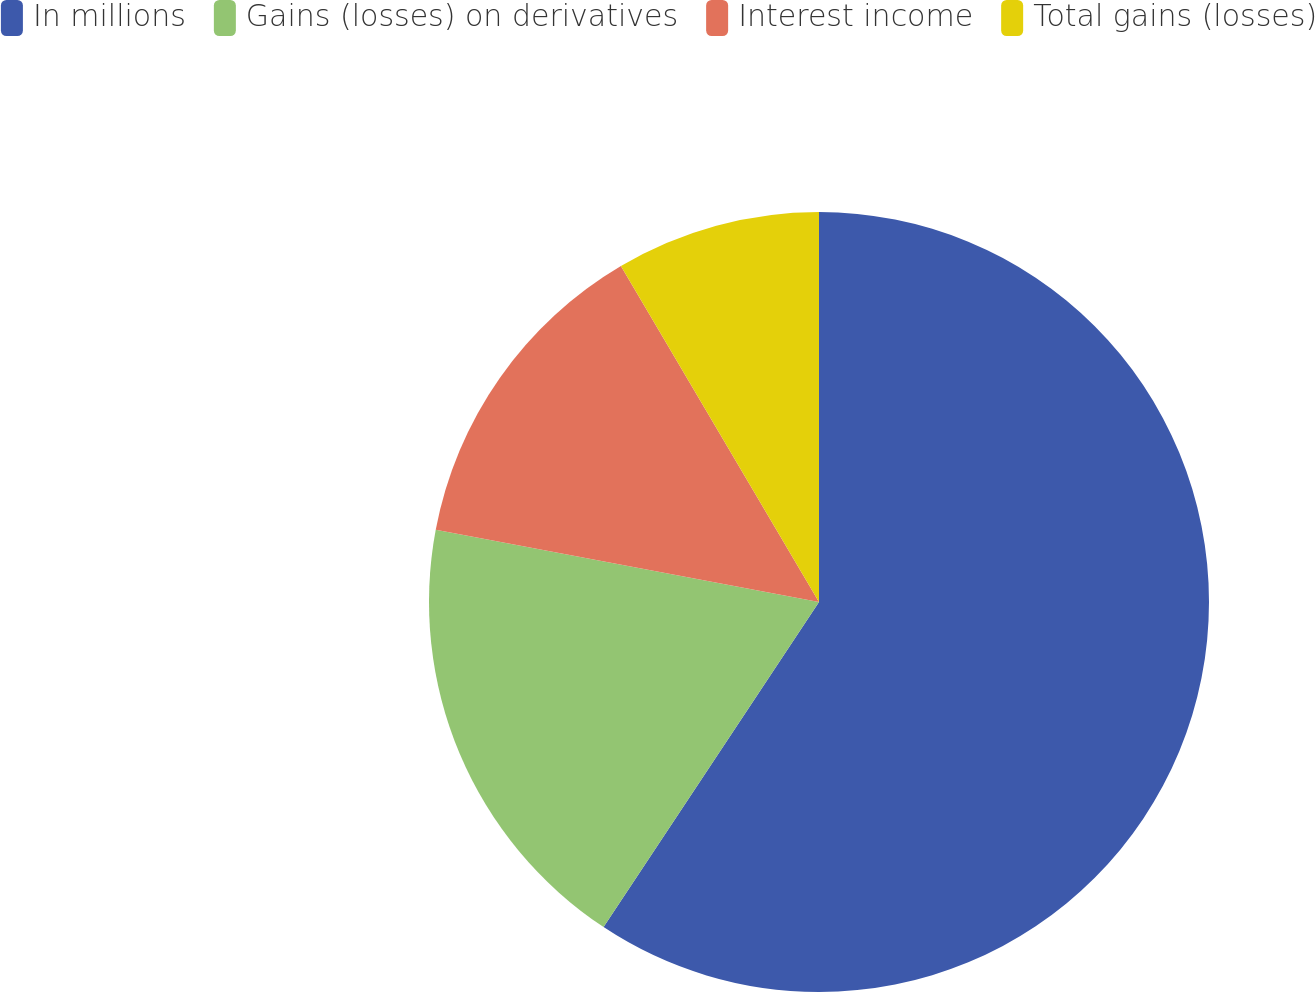Convert chart to OTSL. <chart><loc_0><loc_0><loc_500><loc_500><pie_chart><fcel>In millions<fcel>Gains (losses) on derivatives<fcel>Interest income<fcel>Total gains (losses)<nl><fcel>59.32%<fcel>18.65%<fcel>13.56%<fcel>8.48%<nl></chart> 